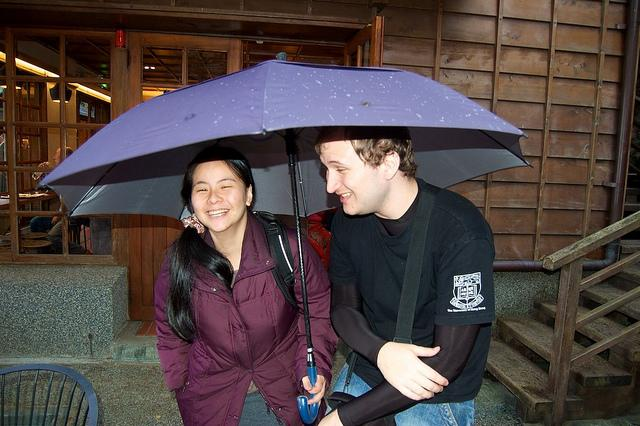What is starting here? Please explain your reasoning. rain. The rain is starting. 